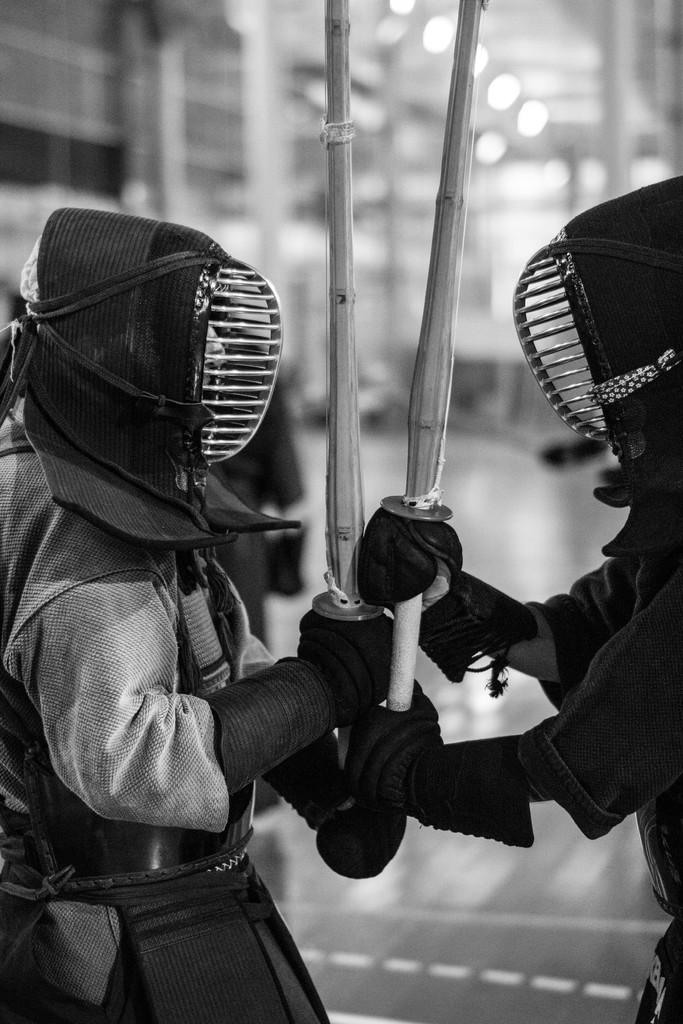What type of picture is in the image? The image contains a black and white picture. How many people are in the picture? There are two persons in the picture. What are the persons wearing? The persons are wearing costumes. What are the persons holding in their hands? The persons are holding sticks in their hands. Can you describe the background of the picture? The background of the picture is blurry. What type of mountain can be seen in the background of the image? There is no mountain visible in the image; the background is blurry. What is the nature of the argument between the two persons in the image? There is no argument depicted in the image; the persons are simply wearing costumes and holding sticks. 